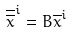<formula> <loc_0><loc_0><loc_500><loc_500>\overline { \overline { x } } ^ { i } = B \overline { x } ^ { i }</formula> 